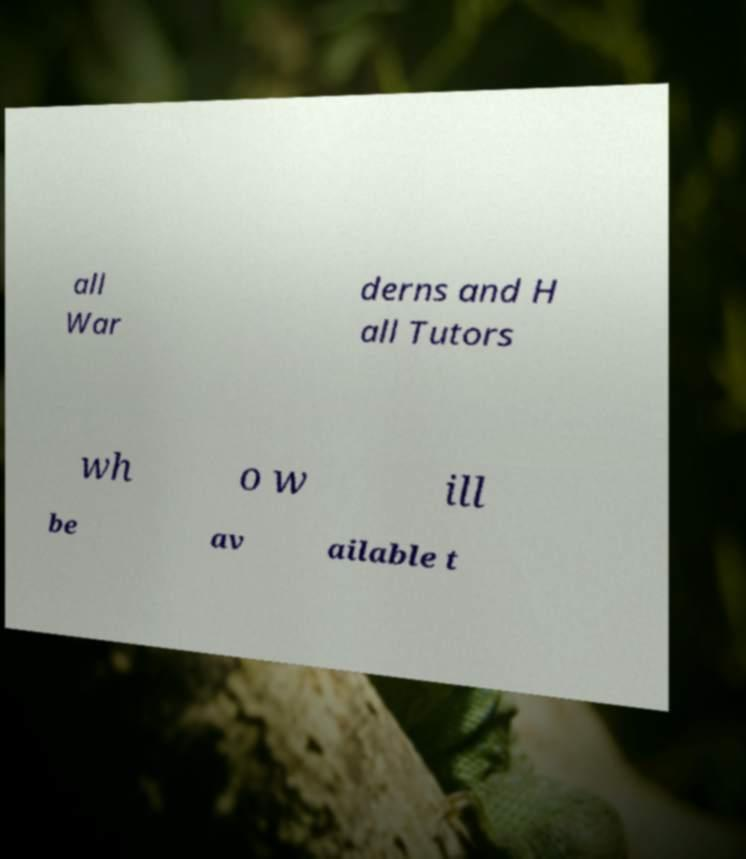What messages or text are displayed in this image? I need them in a readable, typed format. all War derns and H all Tutors wh o w ill be av ailable t 